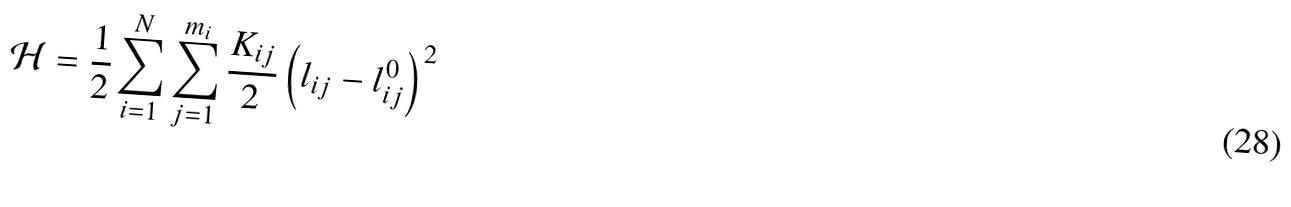<formula> <loc_0><loc_0><loc_500><loc_500>\mathcal { H } = \frac { 1 } { 2 } \sum _ { i = 1 } ^ { N } \sum _ { j = 1 } ^ { m _ { i } } \frac { K _ { i j } } { 2 } \left ( l _ { i j } - l _ { i j } ^ { 0 } \right ) ^ { 2 }</formula> 